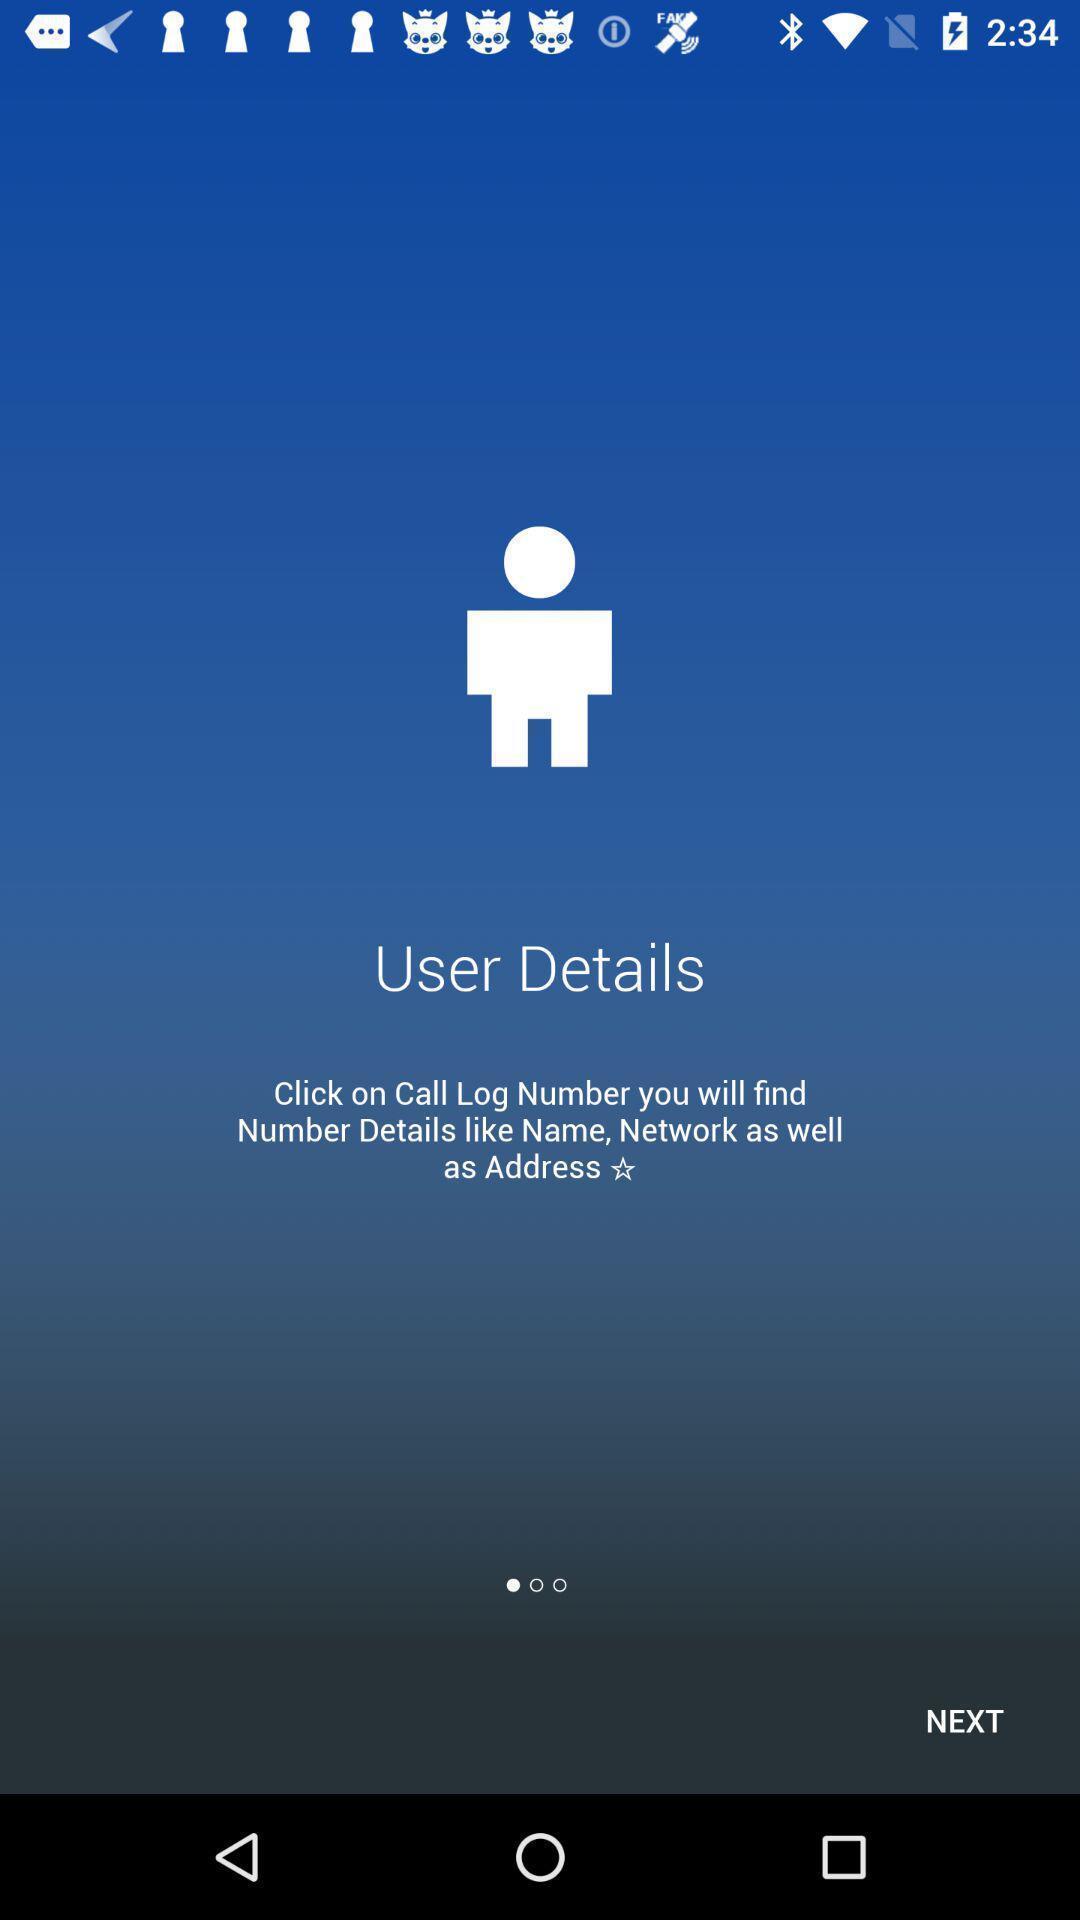What details can you identify in this image? Welcome page for a caller details finding app. 